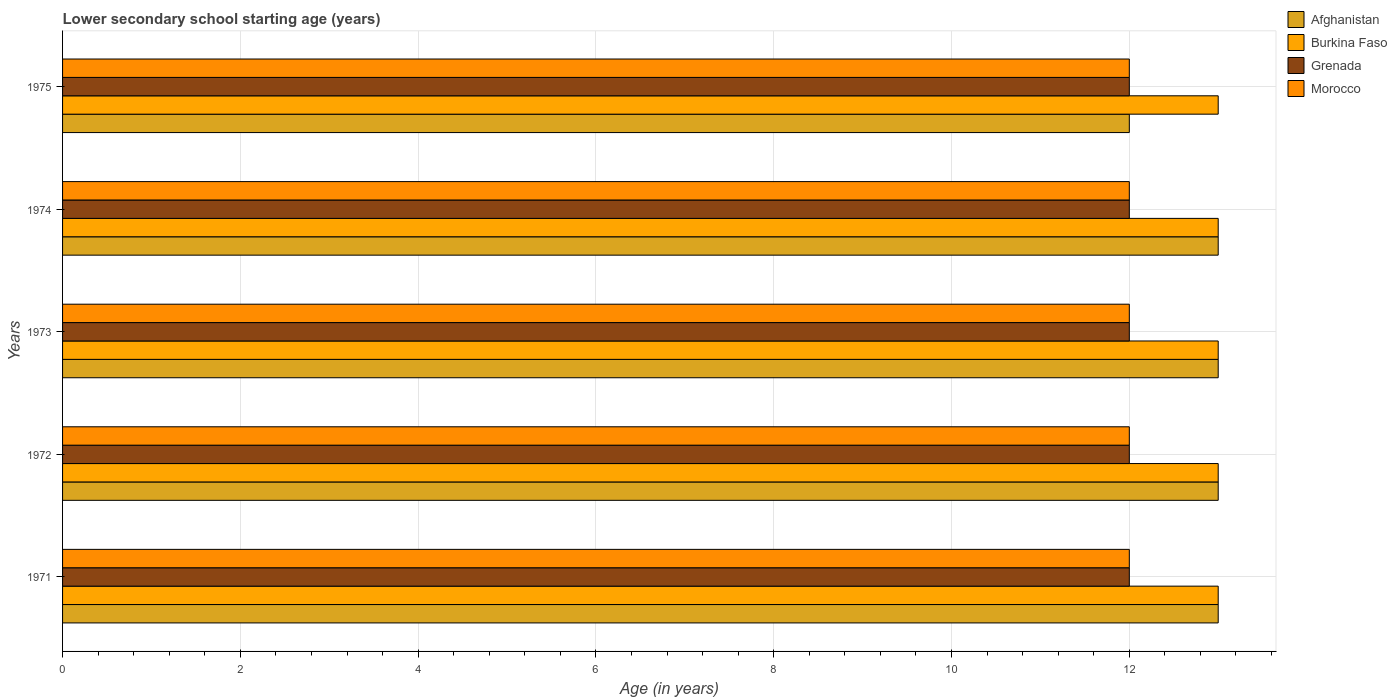How many different coloured bars are there?
Keep it short and to the point. 4. Are the number of bars per tick equal to the number of legend labels?
Your answer should be compact. Yes. Are the number of bars on each tick of the Y-axis equal?
Offer a terse response. Yes. How many bars are there on the 3rd tick from the top?
Your response must be concise. 4. How many bars are there on the 3rd tick from the bottom?
Make the answer very short. 4. What is the label of the 2nd group of bars from the top?
Ensure brevity in your answer.  1974. What is the lower secondary school starting age of children in Morocco in 1973?
Provide a short and direct response. 12. Across all years, what is the maximum lower secondary school starting age of children in Morocco?
Ensure brevity in your answer.  12. Across all years, what is the minimum lower secondary school starting age of children in Morocco?
Make the answer very short. 12. In which year was the lower secondary school starting age of children in Grenada maximum?
Make the answer very short. 1971. In which year was the lower secondary school starting age of children in Morocco minimum?
Make the answer very short. 1971. What is the total lower secondary school starting age of children in Morocco in the graph?
Offer a terse response. 60. What is the average lower secondary school starting age of children in Afghanistan per year?
Your response must be concise. 12.8. Is the lower secondary school starting age of children in Burkina Faso in 1971 less than that in 1975?
Your answer should be compact. No. What is the difference between the highest and the second highest lower secondary school starting age of children in Burkina Faso?
Your answer should be compact. 0. In how many years, is the lower secondary school starting age of children in Afghanistan greater than the average lower secondary school starting age of children in Afghanistan taken over all years?
Offer a very short reply. 4. What does the 3rd bar from the top in 1974 represents?
Provide a succinct answer. Burkina Faso. What does the 2nd bar from the bottom in 1975 represents?
Offer a very short reply. Burkina Faso. How many bars are there?
Your response must be concise. 20. How many years are there in the graph?
Give a very brief answer. 5. What is the difference between two consecutive major ticks on the X-axis?
Ensure brevity in your answer.  2. Where does the legend appear in the graph?
Make the answer very short. Top right. What is the title of the graph?
Offer a terse response. Lower secondary school starting age (years). Does "Macao" appear as one of the legend labels in the graph?
Your answer should be very brief. No. What is the label or title of the X-axis?
Your response must be concise. Age (in years). What is the label or title of the Y-axis?
Provide a succinct answer. Years. What is the Age (in years) in Burkina Faso in 1971?
Ensure brevity in your answer.  13. What is the Age (in years) in Morocco in 1971?
Ensure brevity in your answer.  12. What is the Age (in years) in Afghanistan in 1972?
Give a very brief answer. 13. What is the Age (in years) in Grenada in 1972?
Keep it short and to the point. 12. What is the Age (in years) of Afghanistan in 1973?
Your answer should be compact. 13. What is the Age (in years) in Burkina Faso in 1974?
Provide a short and direct response. 13. What is the Age (in years) in Grenada in 1974?
Give a very brief answer. 12. What is the Age (in years) of Afghanistan in 1975?
Offer a very short reply. 12. What is the Age (in years) in Grenada in 1975?
Ensure brevity in your answer.  12. What is the total Age (in years) of Afghanistan in the graph?
Offer a terse response. 64. What is the total Age (in years) of Grenada in the graph?
Your answer should be compact. 60. What is the difference between the Age (in years) of Grenada in 1971 and that in 1972?
Your answer should be very brief. 0. What is the difference between the Age (in years) in Afghanistan in 1971 and that in 1973?
Your response must be concise. 0. What is the difference between the Age (in years) of Burkina Faso in 1971 and that in 1973?
Your response must be concise. 0. What is the difference between the Age (in years) of Grenada in 1971 and that in 1973?
Make the answer very short. 0. What is the difference between the Age (in years) of Morocco in 1971 and that in 1973?
Provide a short and direct response. 0. What is the difference between the Age (in years) in Burkina Faso in 1971 and that in 1974?
Your response must be concise. 0. What is the difference between the Age (in years) in Morocco in 1971 and that in 1974?
Offer a very short reply. 0. What is the difference between the Age (in years) of Afghanistan in 1971 and that in 1975?
Ensure brevity in your answer.  1. What is the difference between the Age (in years) in Grenada in 1971 and that in 1975?
Offer a very short reply. 0. What is the difference between the Age (in years) in Afghanistan in 1972 and that in 1973?
Provide a succinct answer. 0. What is the difference between the Age (in years) in Burkina Faso in 1972 and that in 1974?
Your answer should be compact. 0. What is the difference between the Age (in years) of Grenada in 1972 and that in 1975?
Offer a terse response. 0. What is the difference between the Age (in years) in Morocco in 1972 and that in 1975?
Provide a succinct answer. 0. What is the difference between the Age (in years) of Afghanistan in 1973 and that in 1974?
Make the answer very short. 0. What is the difference between the Age (in years) of Burkina Faso in 1973 and that in 1974?
Give a very brief answer. 0. What is the difference between the Age (in years) in Grenada in 1973 and that in 1974?
Your answer should be compact. 0. What is the difference between the Age (in years) of Afghanistan in 1973 and that in 1975?
Keep it short and to the point. 1. What is the difference between the Age (in years) in Morocco in 1974 and that in 1975?
Offer a very short reply. 0. What is the difference between the Age (in years) in Afghanistan in 1971 and the Age (in years) in Burkina Faso in 1972?
Offer a very short reply. 0. What is the difference between the Age (in years) in Afghanistan in 1971 and the Age (in years) in Grenada in 1972?
Provide a succinct answer. 1. What is the difference between the Age (in years) of Afghanistan in 1971 and the Age (in years) of Morocco in 1972?
Give a very brief answer. 1. What is the difference between the Age (in years) in Burkina Faso in 1971 and the Age (in years) in Morocco in 1972?
Keep it short and to the point. 1. What is the difference between the Age (in years) in Grenada in 1971 and the Age (in years) in Morocco in 1972?
Provide a succinct answer. 0. What is the difference between the Age (in years) of Afghanistan in 1971 and the Age (in years) of Morocco in 1973?
Your response must be concise. 1. What is the difference between the Age (in years) in Burkina Faso in 1971 and the Age (in years) in Grenada in 1973?
Keep it short and to the point. 1. What is the difference between the Age (in years) of Grenada in 1971 and the Age (in years) of Morocco in 1973?
Provide a short and direct response. 0. What is the difference between the Age (in years) of Afghanistan in 1971 and the Age (in years) of Burkina Faso in 1974?
Your answer should be very brief. 0. What is the difference between the Age (in years) of Afghanistan in 1971 and the Age (in years) of Morocco in 1974?
Your answer should be very brief. 1. What is the difference between the Age (in years) of Grenada in 1971 and the Age (in years) of Morocco in 1974?
Ensure brevity in your answer.  0. What is the difference between the Age (in years) in Afghanistan in 1971 and the Age (in years) in Burkina Faso in 1975?
Provide a succinct answer. 0. What is the difference between the Age (in years) in Afghanistan in 1971 and the Age (in years) in Grenada in 1975?
Provide a succinct answer. 1. What is the difference between the Age (in years) in Burkina Faso in 1971 and the Age (in years) in Morocco in 1975?
Ensure brevity in your answer.  1. What is the difference between the Age (in years) of Afghanistan in 1972 and the Age (in years) of Morocco in 1973?
Provide a short and direct response. 1. What is the difference between the Age (in years) of Burkina Faso in 1972 and the Age (in years) of Morocco in 1973?
Your answer should be compact. 1. What is the difference between the Age (in years) in Grenada in 1972 and the Age (in years) in Morocco in 1973?
Offer a terse response. 0. What is the difference between the Age (in years) of Afghanistan in 1972 and the Age (in years) of Burkina Faso in 1974?
Provide a succinct answer. 0. What is the difference between the Age (in years) in Burkina Faso in 1972 and the Age (in years) in Grenada in 1974?
Your answer should be very brief. 1. What is the difference between the Age (in years) of Burkina Faso in 1972 and the Age (in years) of Morocco in 1974?
Your response must be concise. 1. What is the difference between the Age (in years) of Grenada in 1972 and the Age (in years) of Morocco in 1974?
Your answer should be very brief. 0. What is the difference between the Age (in years) in Afghanistan in 1972 and the Age (in years) in Burkina Faso in 1975?
Give a very brief answer. 0. What is the difference between the Age (in years) of Burkina Faso in 1972 and the Age (in years) of Morocco in 1975?
Ensure brevity in your answer.  1. What is the difference between the Age (in years) of Afghanistan in 1973 and the Age (in years) of Burkina Faso in 1974?
Ensure brevity in your answer.  0. What is the difference between the Age (in years) of Afghanistan in 1973 and the Age (in years) of Morocco in 1974?
Give a very brief answer. 1. What is the difference between the Age (in years) in Burkina Faso in 1973 and the Age (in years) in Morocco in 1974?
Your response must be concise. 1. What is the difference between the Age (in years) in Grenada in 1973 and the Age (in years) in Morocco in 1974?
Your answer should be very brief. 0. What is the difference between the Age (in years) in Afghanistan in 1973 and the Age (in years) in Morocco in 1975?
Offer a terse response. 1. What is the difference between the Age (in years) of Burkina Faso in 1973 and the Age (in years) of Grenada in 1975?
Ensure brevity in your answer.  1. What is the difference between the Age (in years) of Burkina Faso in 1973 and the Age (in years) of Morocco in 1975?
Your answer should be compact. 1. What is the difference between the Age (in years) in Grenada in 1973 and the Age (in years) in Morocco in 1975?
Offer a very short reply. 0. What is the difference between the Age (in years) in Afghanistan in 1974 and the Age (in years) in Burkina Faso in 1975?
Your response must be concise. 0. What is the difference between the Age (in years) in Afghanistan in 1974 and the Age (in years) in Morocco in 1975?
Your answer should be very brief. 1. What is the difference between the Age (in years) in Burkina Faso in 1974 and the Age (in years) in Grenada in 1975?
Your response must be concise. 1. What is the average Age (in years) in Burkina Faso per year?
Your response must be concise. 13. What is the average Age (in years) of Grenada per year?
Provide a succinct answer. 12. In the year 1971, what is the difference between the Age (in years) in Afghanistan and Age (in years) in Burkina Faso?
Your answer should be very brief. 0. In the year 1971, what is the difference between the Age (in years) in Burkina Faso and Age (in years) in Morocco?
Offer a terse response. 1. In the year 1971, what is the difference between the Age (in years) in Grenada and Age (in years) in Morocco?
Your response must be concise. 0. In the year 1972, what is the difference between the Age (in years) of Afghanistan and Age (in years) of Grenada?
Your response must be concise. 1. In the year 1973, what is the difference between the Age (in years) of Afghanistan and Age (in years) of Burkina Faso?
Keep it short and to the point. 0. In the year 1973, what is the difference between the Age (in years) of Afghanistan and Age (in years) of Morocco?
Keep it short and to the point. 1. In the year 1973, what is the difference between the Age (in years) in Burkina Faso and Age (in years) in Morocco?
Offer a very short reply. 1. In the year 1974, what is the difference between the Age (in years) in Afghanistan and Age (in years) in Burkina Faso?
Offer a very short reply. 0. In the year 1974, what is the difference between the Age (in years) of Afghanistan and Age (in years) of Grenada?
Ensure brevity in your answer.  1. In the year 1974, what is the difference between the Age (in years) in Burkina Faso and Age (in years) in Grenada?
Your answer should be compact. 1. In the year 1975, what is the difference between the Age (in years) in Afghanistan and Age (in years) in Grenada?
Your answer should be compact. 0. In the year 1975, what is the difference between the Age (in years) of Afghanistan and Age (in years) of Morocco?
Your response must be concise. 0. What is the ratio of the Age (in years) of Burkina Faso in 1971 to that in 1972?
Offer a very short reply. 1. What is the ratio of the Age (in years) in Burkina Faso in 1971 to that in 1973?
Your response must be concise. 1. What is the ratio of the Age (in years) of Grenada in 1971 to that in 1973?
Offer a terse response. 1. What is the ratio of the Age (in years) of Afghanistan in 1971 to that in 1974?
Your answer should be compact. 1. What is the ratio of the Age (in years) of Burkina Faso in 1971 to that in 1974?
Offer a terse response. 1. What is the ratio of the Age (in years) in Afghanistan in 1971 to that in 1975?
Keep it short and to the point. 1.08. What is the ratio of the Age (in years) in Burkina Faso in 1971 to that in 1975?
Give a very brief answer. 1. What is the ratio of the Age (in years) in Grenada in 1971 to that in 1975?
Your answer should be compact. 1. What is the ratio of the Age (in years) in Grenada in 1972 to that in 1973?
Your response must be concise. 1. What is the ratio of the Age (in years) of Morocco in 1972 to that in 1973?
Your response must be concise. 1. What is the ratio of the Age (in years) in Afghanistan in 1972 to that in 1974?
Your answer should be compact. 1. What is the ratio of the Age (in years) in Burkina Faso in 1972 to that in 1974?
Keep it short and to the point. 1. What is the ratio of the Age (in years) in Afghanistan in 1972 to that in 1975?
Ensure brevity in your answer.  1.08. What is the ratio of the Age (in years) of Morocco in 1972 to that in 1975?
Keep it short and to the point. 1. What is the ratio of the Age (in years) of Burkina Faso in 1973 to that in 1974?
Your response must be concise. 1. What is the ratio of the Age (in years) in Morocco in 1973 to that in 1974?
Provide a short and direct response. 1. What is the ratio of the Age (in years) in Afghanistan in 1973 to that in 1975?
Provide a succinct answer. 1.08. What is the ratio of the Age (in years) of Burkina Faso in 1973 to that in 1975?
Give a very brief answer. 1. What is the ratio of the Age (in years) of Grenada in 1973 to that in 1975?
Make the answer very short. 1. What is the ratio of the Age (in years) in Burkina Faso in 1974 to that in 1975?
Offer a very short reply. 1. What is the ratio of the Age (in years) of Morocco in 1974 to that in 1975?
Ensure brevity in your answer.  1. What is the difference between the highest and the second highest Age (in years) in Afghanistan?
Your answer should be compact. 0. What is the difference between the highest and the second highest Age (in years) of Grenada?
Keep it short and to the point. 0. What is the difference between the highest and the lowest Age (in years) in Afghanistan?
Keep it short and to the point. 1. What is the difference between the highest and the lowest Age (in years) in Grenada?
Offer a terse response. 0. 